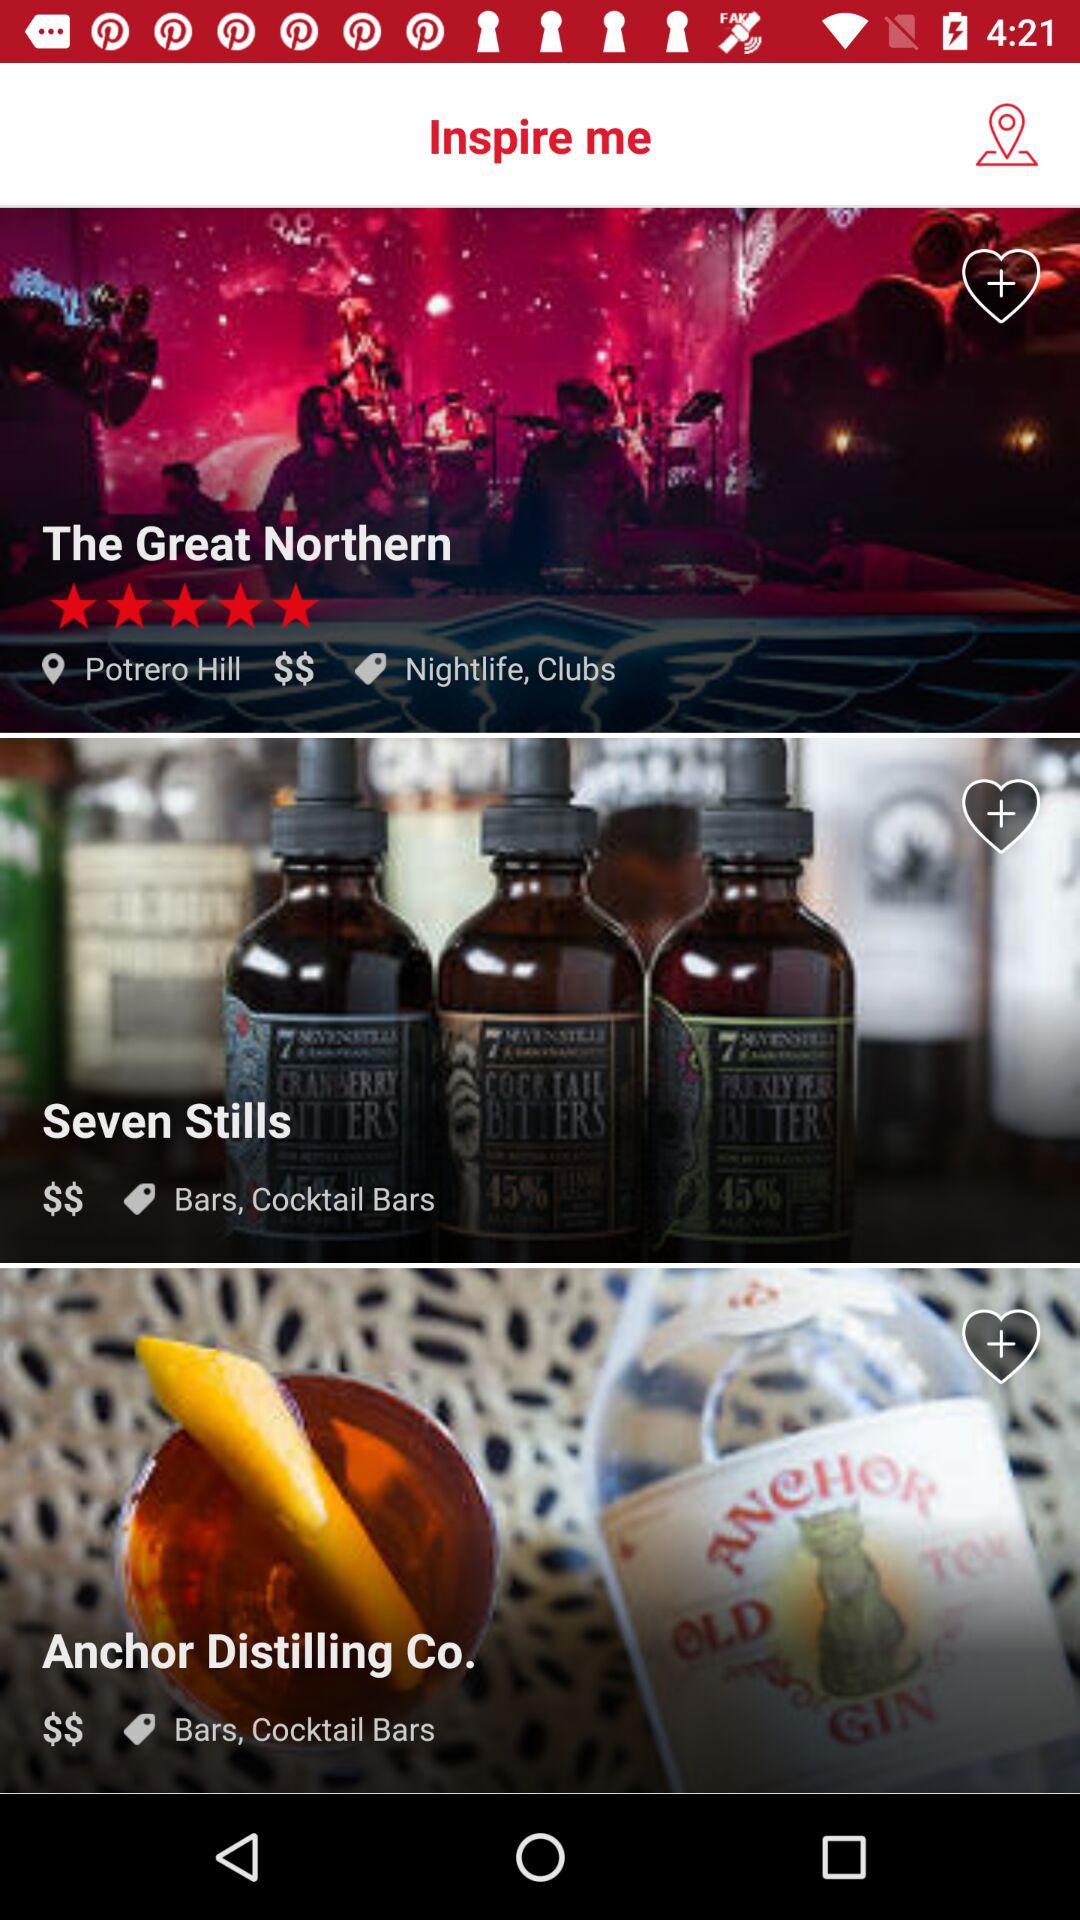What is the location of "The Great Northern"? The location is Potrero Hill. 